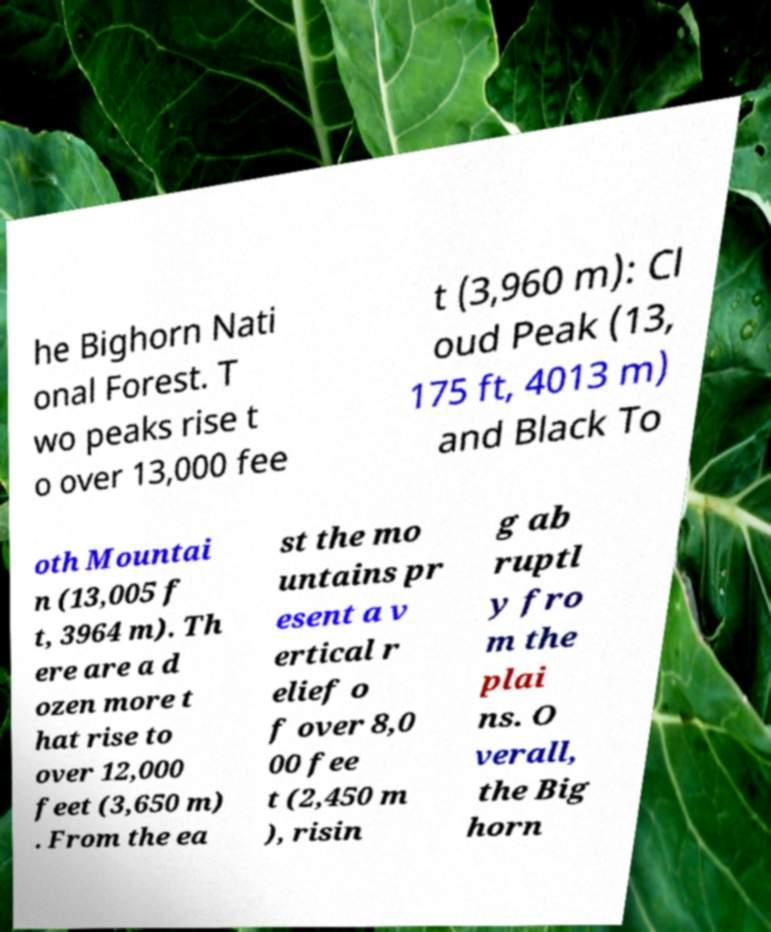Could you assist in decoding the text presented in this image and type it out clearly? he Bighorn Nati onal Forest. T wo peaks rise t o over 13,000 fee t (3,960 m): Cl oud Peak (13, 175 ft, 4013 m) and Black To oth Mountai n (13,005 f t, 3964 m). Th ere are a d ozen more t hat rise to over 12,000 feet (3,650 m) . From the ea st the mo untains pr esent a v ertical r elief o f over 8,0 00 fee t (2,450 m ), risin g ab ruptl y fro m the plai ns. O verall, the Big horn 